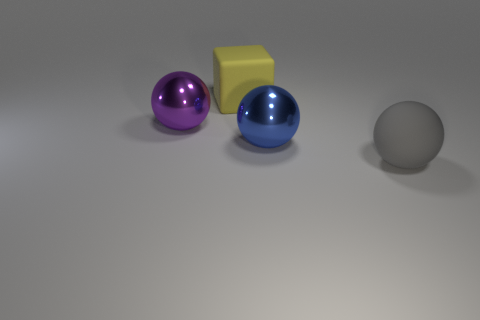How many objects are big rubber objects that are right of the large yellow matte block or large objects?
Give a very brief answer. 4. The yellow matte thing has what size?
Make the answer very short. Large. There is a object behind the big object that is to the left of the big yellow block; what is its material?
Keep it short and to the point. Rubber. There is a matte object behind the purple metal sphere; is it the same size as the matte ball?
Provide a succinct answer. Yes. Are there any large matte objects of the same color as the big cube?
Keep it short and to the point. No. How many things are either large balls behind the big gray ball or big things that are to the left of the big matte ball?
Provide a succinct answer. 3. Is the number of big yellow matte cubes behind the large purple object less than the number of large objects that are behind the gray ball?
Make the answer very short. Yes. Is the material of the big blue object the same as the purple thing?
Ensure brevity in your answer.  Yes. What is the shape of the blue object that is the same size as the purple metallic sphere?
Provide a succinct answer. Sphere. The thing right of the metallic object that is right of the big yellow rubber object right of the purple thing is made of what material?
Keep it short and to the point. Rubber. 